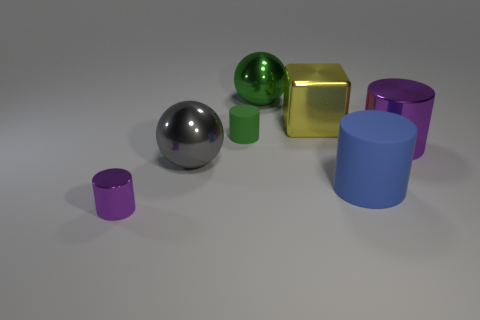Is the yellow thing the same shape as the large purple metallic thing? no 